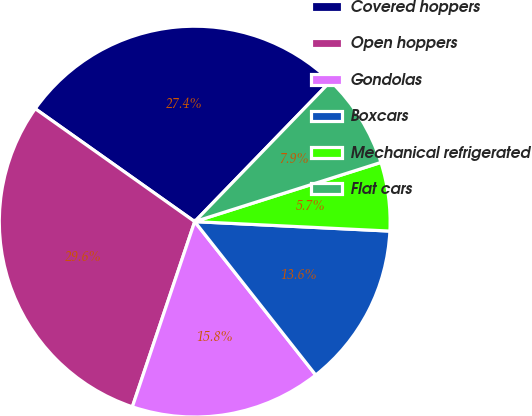Convert chart to OTSL. <chart><loc_0><loc_0><loc_500><loc_500><pie_chart><fcel>Covered hoppers<fcel>Open hoppers<fcel>Gondolas<fcel>Boxcars<fcel>Mechanical refrigerated<fcel>Flat cars<nl><fcel>27.44%<fcel>29.64%<fcel>15.8%<fcel>13.6%<fcel>5.67%<fcel>7.86%<nl></chart> 